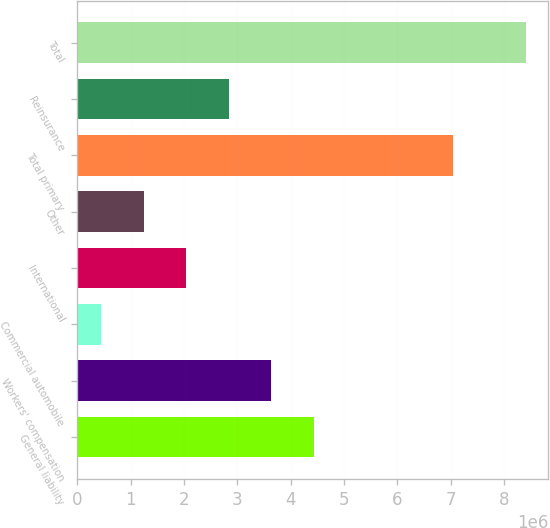<chart> <loc_0><loc_0><loc_500><loc_500><bar_chart><fcel>General liability<fcel>Workers' compensation<fcel>Commercial automobile<fcel>International<fcel>Other<fcel>Total primary<fcel>Reinsurance<fcel>Total<nl><fcel>4.4284e+06<fcel>3.63171e+06<fcel>444957<fcel>2.03834e+06<fcel>1.24165e+06<fcel>7.03423e+06<fcel>2.83503e+06<fcel>8.41185e+06<nl></chart> 